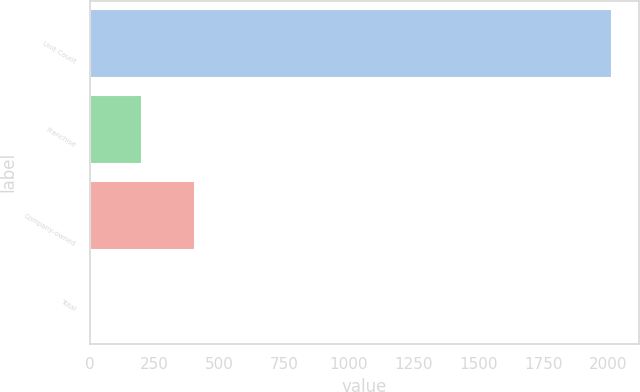<chart> <loc_0><loc_0><loc_500><loc_500><bar_chart><fcel>Unit Count<fcel>Franchise<fcel>Company-owned<fcel>Total<nl><fcel>2017<fcel>203.5<fcel>405<fcel>2<nl></chart> 